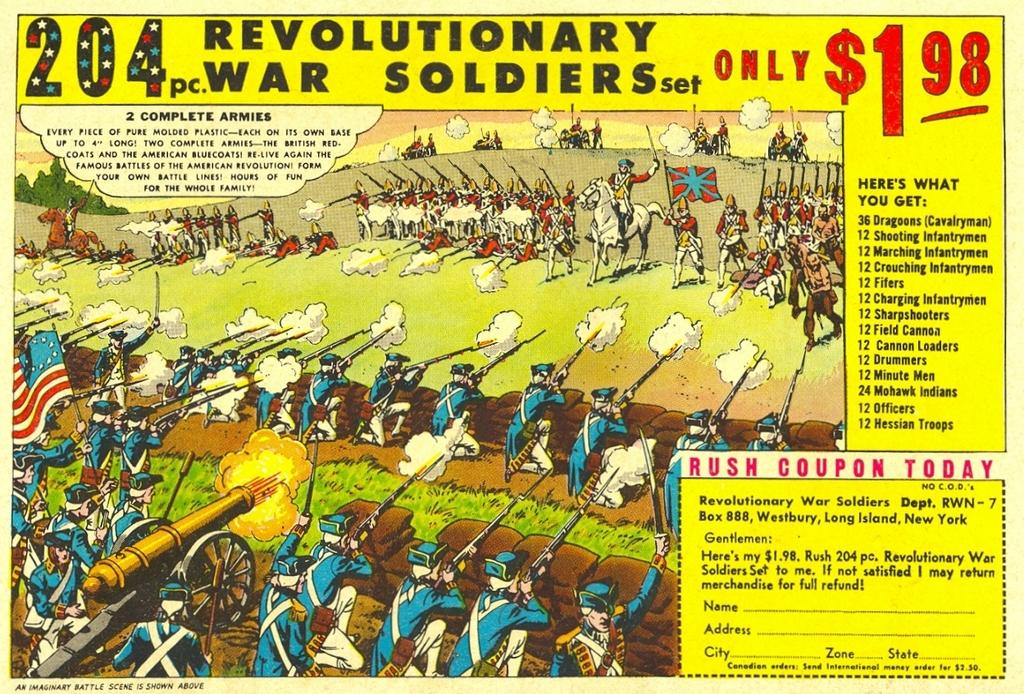<image>
Render a clear and concise summary of the photo. a group of soldiers on a postcard that sells for 1.98 